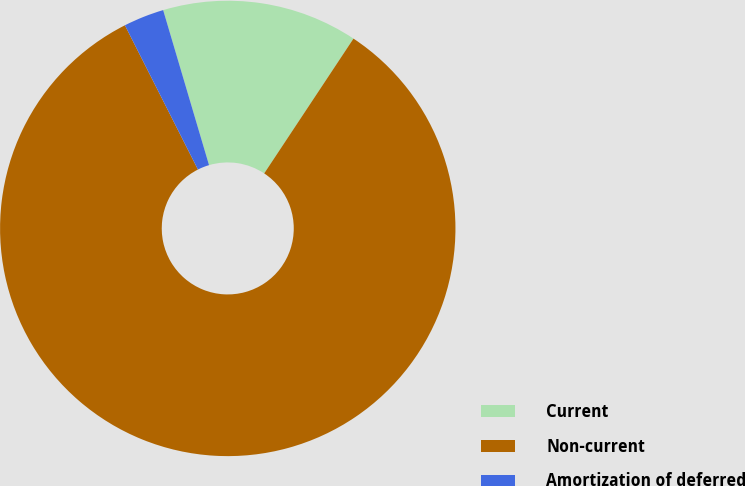Convert chart to OTSL. <chart><loc_0><loc_0><loc_500><loc_500><pie_chart><fcel>Current<fcel>Non-current<fcel>Amortization of deferred<nl><fcel>13.89%<fcel>83.23%<fcel>2.88%<nl></chart> 